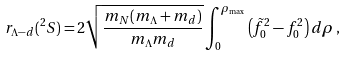<formula> <loc_0><loc_0><loc_500><loc_500>r _ { \Lambda - d } ( ^ { 2 } S ) = 2 \sqrt { \frac { m _ { N } ( m _ { \Lambda } + m _ { d } ) } { m _ { \Lambda } m _ { d } } } \int _ { 0 } ^ { \rho _ { \max } } \left ( \tilde { f } _ { 0 } ^ { 2 } - { f } _ { 0 } ^ { 2 } \right ) d \rho \, ,</formula> 